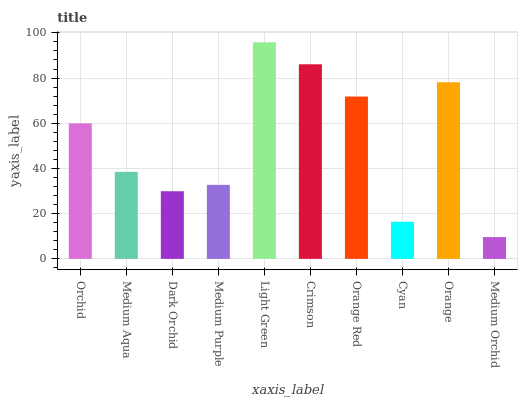Is Medium Orchid the minimum?
Answer yes or no. Yes. Is Light Green the maximum?
Answer yes or no. Yes. Is Medium Aqua the minimum?
Answer yes or no. No. Is Medium Aqua the maximum?
Answer yes or no. No. Is Orchid greater than Medium Aqua?
Answer yes or no. Yes. Is Medium Aqua less than Orchid?
Answer yes or no. Yes. Is Medium Aqua greater than Orchid?
Answer yes or no. No. Is Orchid less than Medium Aqua?
Answer yes or no. No. Is Orchid the high median?
Answer yes or no. Yes. Is Medium Aqua the low median?
Answer yes or no. Yes. Is Crimson the high median?
Answer yes or no. No. Is Crimson the low median?
Answer yes or no. No. 